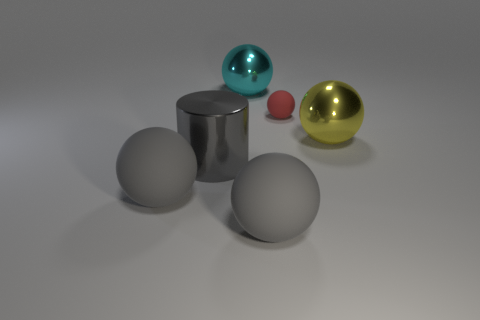Is there any other thing that has the same size as the red rubber thing?
Keep it short and to the point. No. How many big metal objects are both in front of the big yellow metallic thing and on the right side of the small red object?
Offer a terse response. 0. There is a small matte object; is it the same shape as the big gray matte thing left of the gray metal thing?
Offer a terse response. Yes. Is the number of large metallic cylinders that are behind the small red object greater than the number of big gray cylinders?
Offer a terse response. No. Are there fewer gray things in front of the gray cylinder than gray matte spheres?
Provide a succinct answer. No. How many metallic cylinders are the same color as the tiny ball?
Offer a terse response. 0. What material is the large sphere that is both behind the cylinder and on the left side of the big yellow thing?
Ensure brevity in your answer.  Metal. Is the color of the large metallic ball that is to the right of the cyan ball the same as the sphere behind the red object?
Your answer should be compact. No. What number of yellow things are large metallic cylinders or tiny matte things?
Give a very brief answer. 0. Is the number of things on the right side of the gray metallic cylinder less than the number of tiny red rubber balls that are in front of the small ball?
Ensure brevity in your answer.  No. 